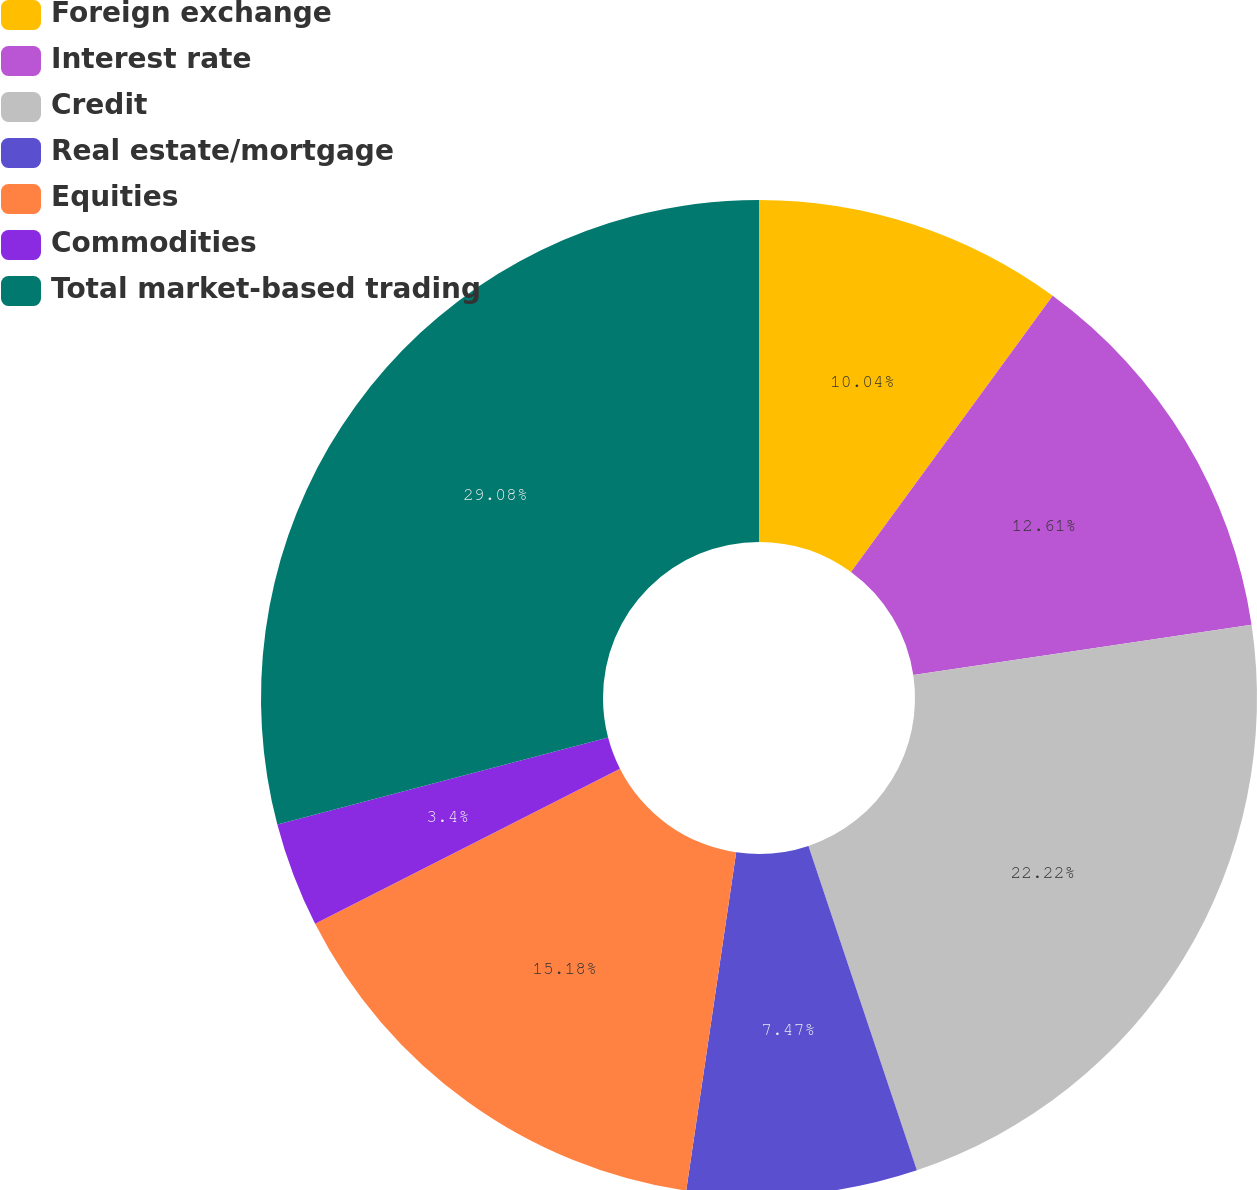Convert chart to OTSL. <chart><loc_0><loc_0><loc_500><loc_500><pie_chart><fcel>Foreign exchange<fcel>Interest rate<fcel>Credit<fcel>Real estate/mortgage<fcel>Equities<fcel>Commodities<fcel>Total market-based trading<nl><fcel>10.04%<fcel>12.61%<fcel>22.22%<fcel>7.47%<fcel>15.18%<fcel>3.4%<fcel>29.09%<nl></chart> 